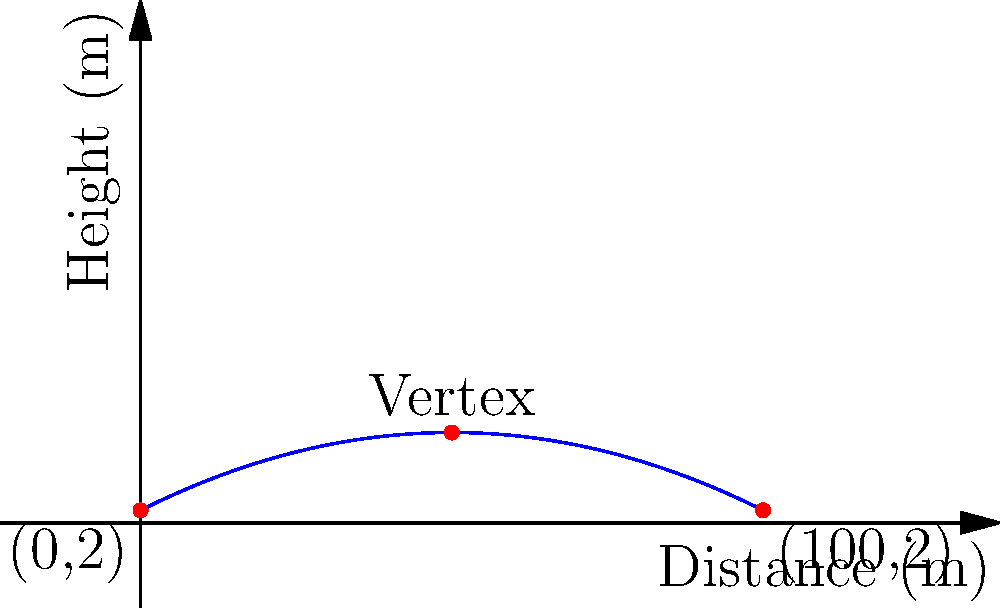During a youth soccer game, you observe a perfectly kicked ball following a parabolic trajectory. The ball is kicked from a height of 2 meters, reaches its maximum height at the midpoint of its horizontal travel, and lands 100 meters away at the same height it was kicked from. Find the equation of the line representing the soccer ball's trajectory in the form $y = ax^2 + bx + c$, where $x$ is the horizontal distance and $y$ is the height in meters. Let's approach this step-by-step:

1) The general form of a parabola is $y = ax^2 + bx + c$.

2) We know three points on this parabola:
   - Starting point: (0, 2)
   - Ending point: (100, 2)
   - Vertex: (50, unknown height)

3) From the starting point (0, 2), we know that $c = 2$.

4) The axis of symmetry is at $x = 50$ (midpoint of horizontal travel).
   For a parabola $y = ax^2 + bx + c$, the axis of symmetry is at $x = -b/(2a)$.
   So, $50 = -b/(2a)$ or $b = -100a$.

5) Now our equation is $y = ax^2 - 100ax + 2$.

6) Use the end point (100, 2) to find $a$:
   $2 = a(100)^2 - 100a(100) + 2$
   $0 = 10000a - 10000a = 0$

   This is always true, so we need another condition.

7) The vertex form of a parabola is $y = a(x-h)^2 + k$, where (h,k) is the vertex.
   Our parabola can be written as $y = a(x-50)^2 + k$.

8) Expand this: $y = ax^2 - 100ax + 2500a + k$
   Comparing with our equation from step 5:
   $2500a + k = 2$

9) The total vertical displacement is 12.5 meters (from 2m to 14.5m).
   In the vertex form, this means $k - 2 = 12.5$, or $k = 14.5$.

10) From step 8 and 9:
    $2500a + 14.5 = 2$
    $2500a = -12.5$
    $a = -0.005$

Therefore, the equation is $y = -0.005x^2 + 0.5x + 2$.
Answer: $y = -0.005x^2 + 0.5x + 2$ 